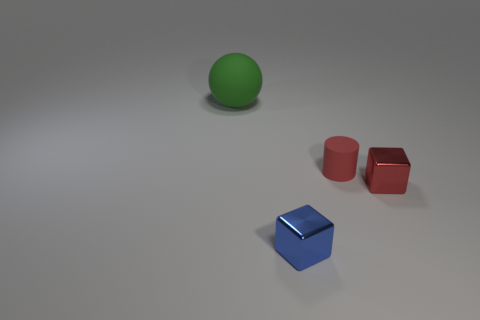Add 4 yellow cubes. How many objects exist? 8 Subtract all spheres. How many objects are left? 3 Subtract all large balls. Subtract all metal cubes. How many objects are left? 1 Add 2 small matte cylinders. How many small matte cylinders are left? 3 Add 1 large red matte blocks. How many large red matte blocks exist? 1 Subtract 0 blue cylinders. How many objects are left? 4 